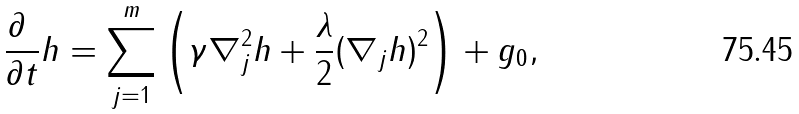<formula> <loc_0><loc_0><loc_500><loc_500>\frac { \partial \ } { \partial t } h = \sum _ { j = 1 } ^ { m } \left ( \gamma \nabla _ { j } ^ { 2 } h + \frac { \lambda } { 2 } ( \nabla _ { j } h ) ^ { 2 } \right ) + g _ { 0 } ,</formula> 